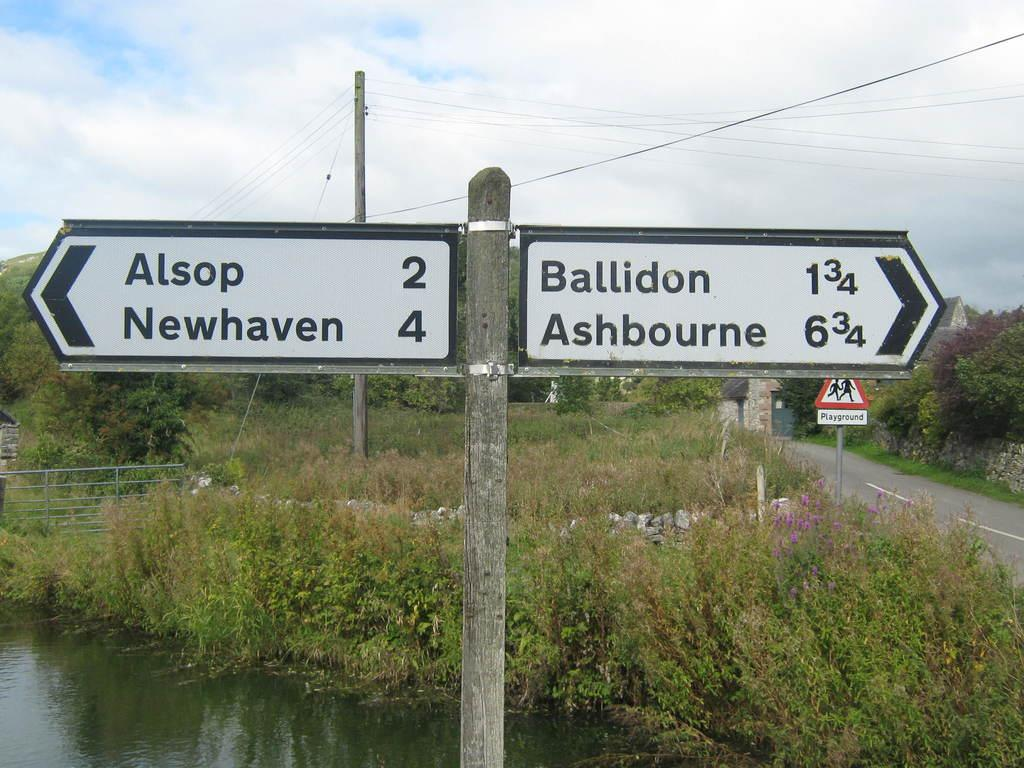<image>
Write a terse but informative summary of the picture. A scene in the country side showing a cross roads sign giving the distance to several towns including Ballidon. 